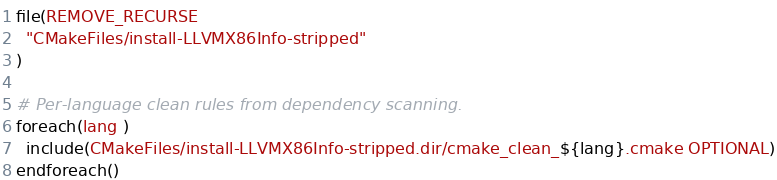<code> <loc_0><loc_0><loc_500><loc_500><_CMake_>file(REMOVE_RECURSE
  "CMakeFiles/install-LLVMX86Info-stripped"
)

# Per-language clean rules from dependency scanning.
foreach(lang )
  include(CMakeFiles/install-LLVMX86Info-stripped.dir/cmake_clean_${lang}.cmake OPTIONAL)
endforeach()
</code> 